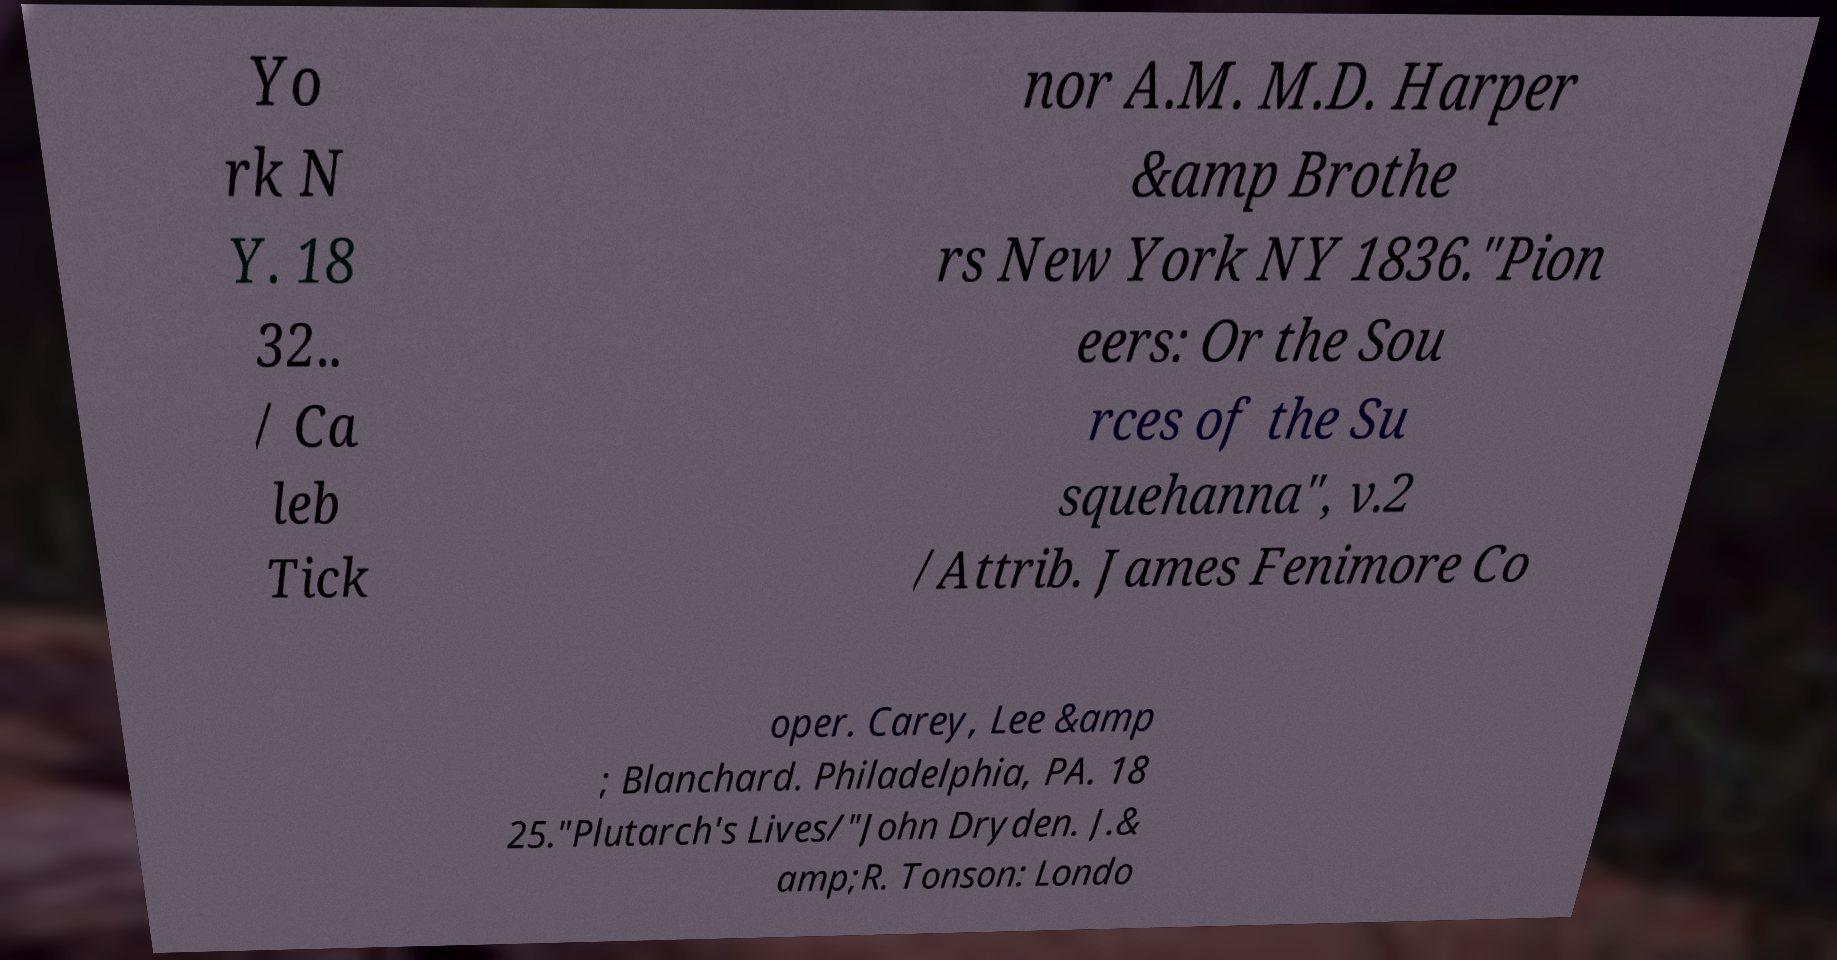There's text embedded in this image that I need extracted. Can you transcribe it verbatim? Yo rk N Y. 18 32.. / Ca leb Tick nor A.M. M.D. Harper &amp Brothe rs New York NY 1836."Pion eers: Or the Sou rces of the Su squehanna", v.2 /Attrib. James Fenimore Co oper. Carey, Lee &amp ; Blanchard. Philadelphia, PA. 18 25."Plutarch's Lives/"John Dryden. J.& amp;R. Tonson: Londo 